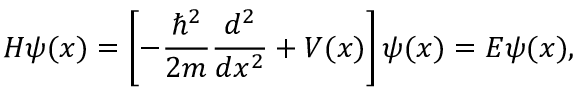<formula> <loc_0><loc_0><loc_500><loc_500>H \psi ( x ) = \left [ - { \frac { \hbar { ^ } { 2 } } { 2 m } } { \frac { d ^ { 2 } } { d x ^ { 2 } } } + V ( x ) \right ] \psi ( x ) = E \psi ( x ) ,</formula> 